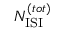<formula> <loc_0><loc_0><loc_500><loc_500>N _ { I S I } ^ { ( t o t ) }</formula> 